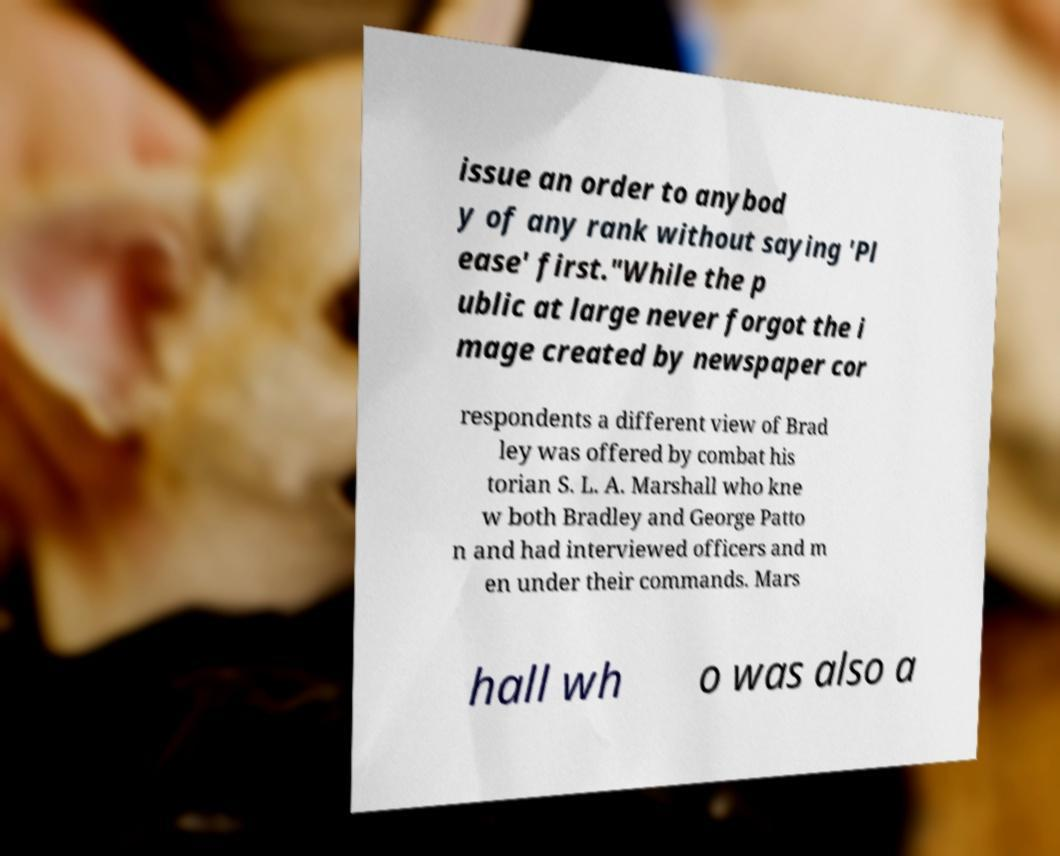Could you extract and type out the text from this image? issue an order to anybod y of any rank without saying 'Pl ease' first."While the p ublic at large never forgot the i mage created by newspaper cor respondents a different view of Brad ley was offered by combat his torian S. L. A. Marshall who kne w both Bradley and George Patto n and had interviewed officers and m en under their commands. Mars hall wh o was also a 